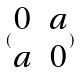<formula> <loc_0><loc_0><loc_500><loc_500>( \begin{matrix} 0 & a \\ a & 0 \end{matrix} )</formula> 